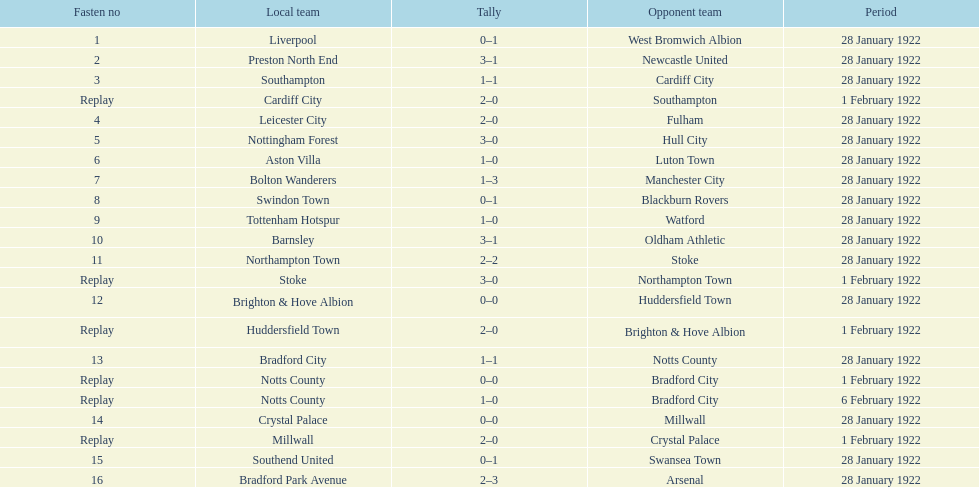How many total points were scored in the second round proper? 45. 